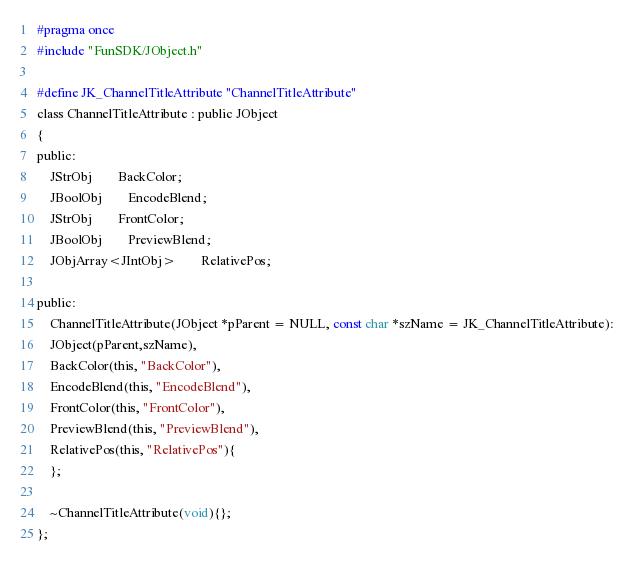Convert code to text. <code><loc_0><loc_0><loc_500><loc_500><_C_>#pragma once
#include "FunSDK/JObject.h"

#define JK_ChannelTitleAttribute "ChannelTitleAttribute"
class ChannelTitleAttribute : public JObject
{
public:
    JStrObj		BackColor;
    JBoolObj		EncodeBlend;
    JStrObj		FrontColor;
    JBoolObj		PreviewBlend;
    JObjArray<JIntObj>		RelativePos;
    
public:
    ChannelTitleAttribute(JObject *pParent = NULL, const char *szName = JK_ChannelTitleAttribute):
    JObject(pParent,szName),
    BackColor(this, "BackColor"),
    EncodeBlend(this, "EncodeBlend"),
    FrontColor(this, "FrontColor"),
    PreviewBlend(this, "PreviewBlend"),
    RelativePos(this, "RelativePos"){
    };
    
    ~ChannelTitleAttribute(void){};
};
</code> 